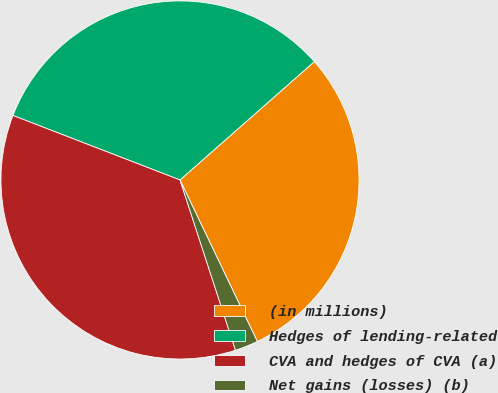Convert chart to OTSL. <chart><loc_0><loc_0><loc_500><loc_500><pie_chart><fcel>(in millions)<fcel>Hedges of lending-related<fcel>CVA and hedges of CVA (a)<fcel>Net gains (losses) (b)<nl><fcel>29.39%<fcel>32.64%<fcel>35.88%<fcel>2.09%<nl></chart> 